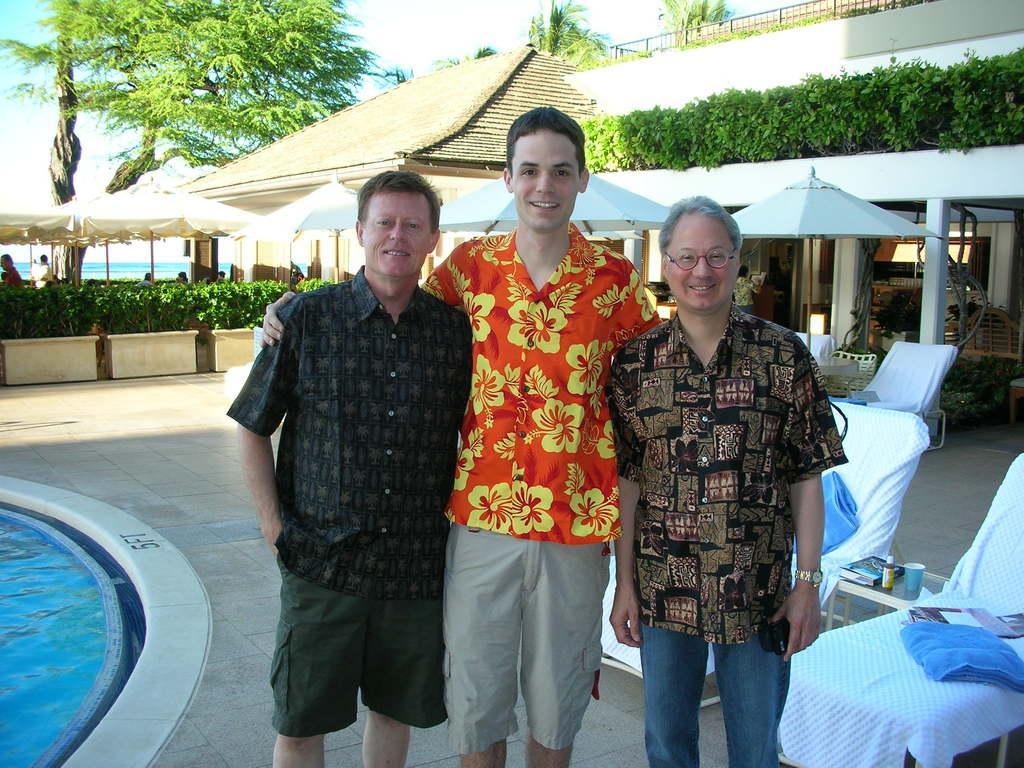Please provide a concise description of this image. In this picture we can see three men standing and smiling. There is a swimming pool on the left side. We can see a cup, bottle and a book on the table. There are towels on the chair on the right side. We can see a few chairs, umbrellas, tents and flower pots on the path. We can see a few trees at the back. There is water in the background. 